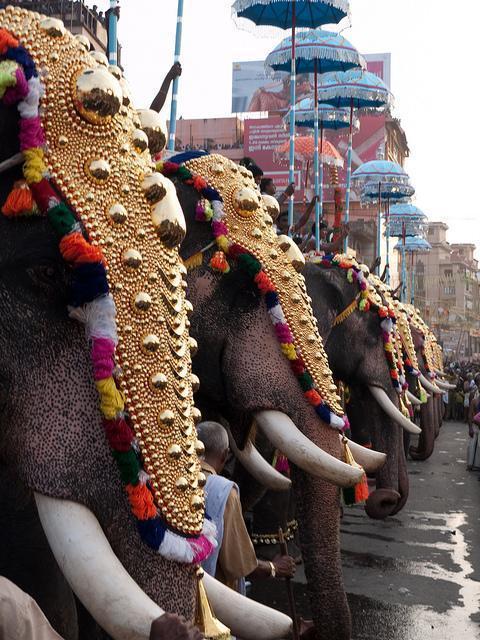How many umbrellas are there?
Give a very brief answer. 3. How many elephants can you see?
Give a very brief answer. 5. 